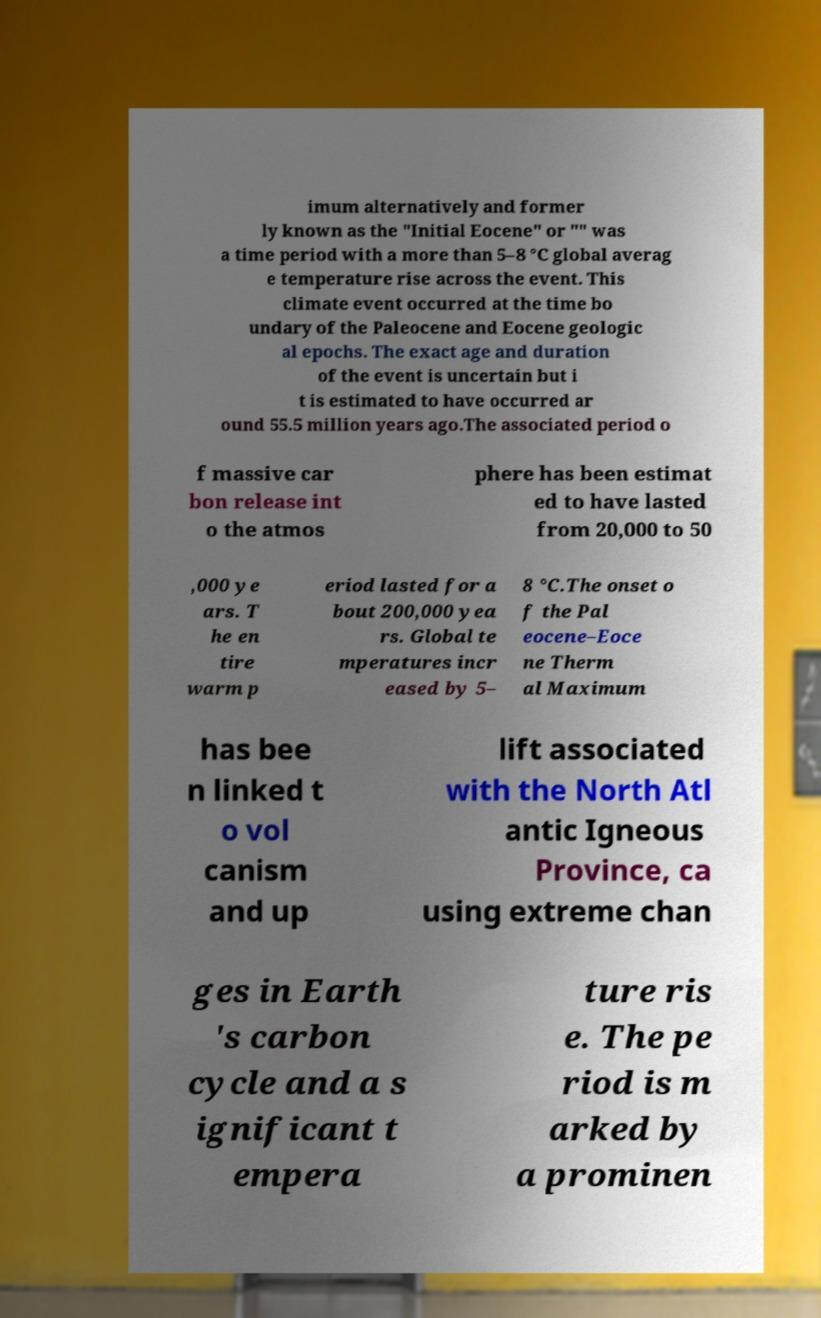I need the written content from this picture converted into text. Can you do that? imum alternatively and former ly known as the "Initial Eocene" or "" was a time period with a more than 5–8 °C global averag e temperature rise across the event. This climate event occurred at the time bo undary of the Paleocene and Eocene geologic al epochs. The exact age and duration of the event is uncertain but i t is estimated to have occurred ar ound 55.5 million years ago.The associated period o f massive car bon release int o the atmos phere has been estimat ed to have lasted from 20,000 to 50 ,000 ye ars. T he en tire warm p eriod lasted for a bout 200,000 yea rs. Global te mperatures incr eased by 5– 8 °C.The onset o f the Pal eocene–Eoce ne Therm al Maximum has bee n linked t o vol canism and up lift associated with the North Atl antic Igneous Province, ca using extreme chan ges in Earth 's carbon cycle and a s ignificant t empera ture ris e. The pe riod is m arked by a prominen 